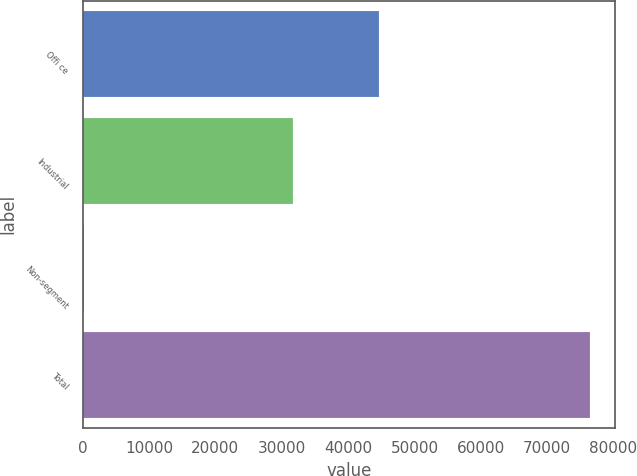<chart> <loc_0><loc_0><loc_500><loc_500><bar_chart><fcel>Offi ce<fcel>Industrial<fcel>Non-segment<fcel>Total<nl><fcel>44602<fcel>31711<fcel>135<fcel>76448<nl></chart> 